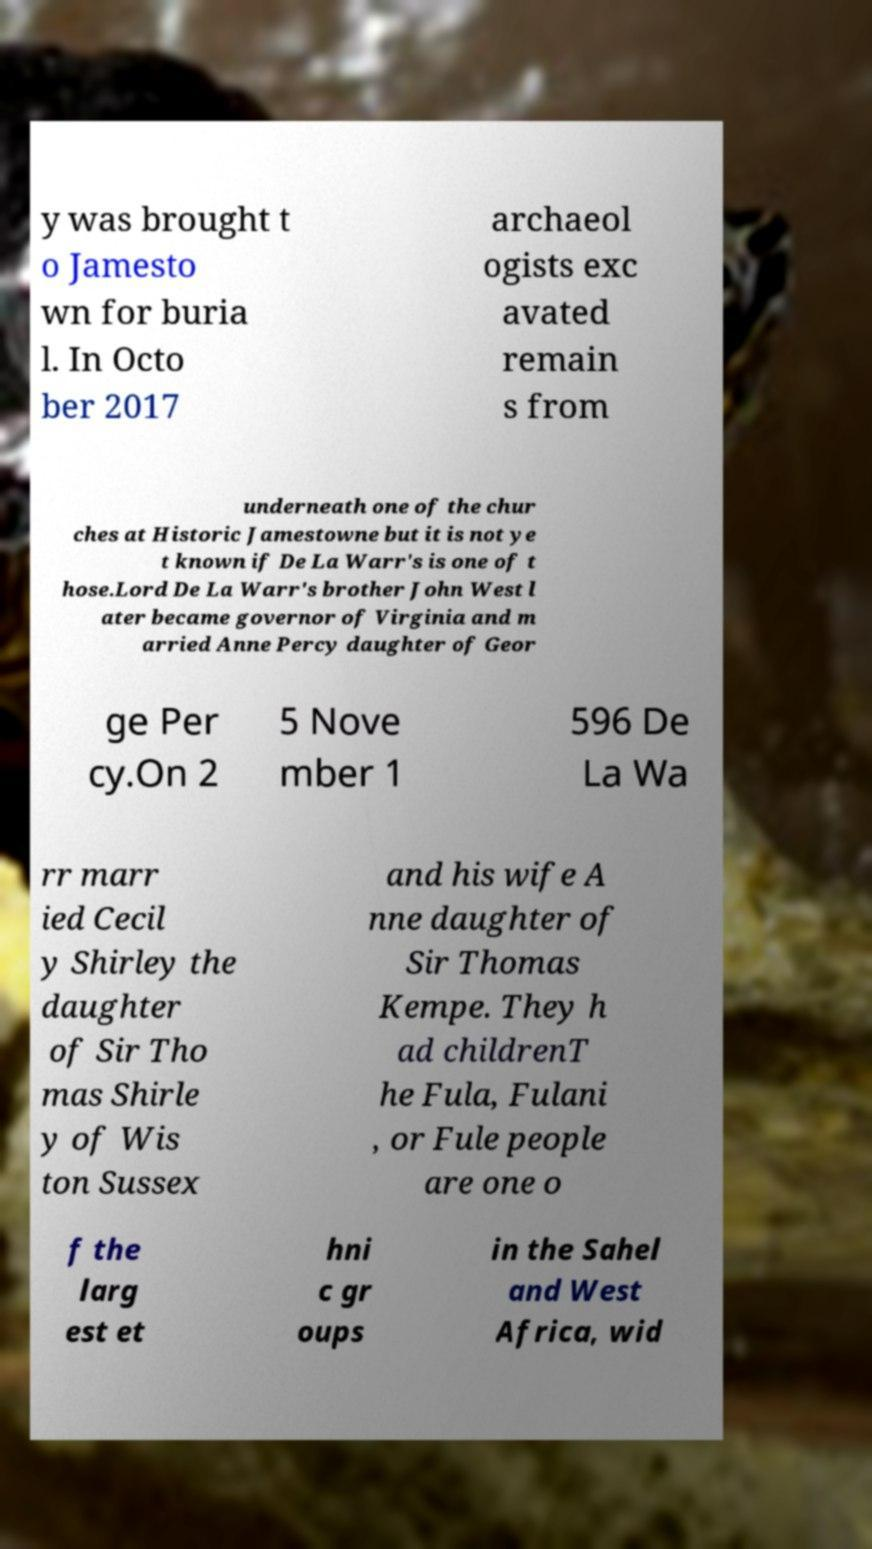Please read and relay the text visible in this image. What does it say? y was brought t o Jamesto wn for buria l. In Octo ber 2017 archaeol ogists exc avated remain s from underneath one of the chur ches at Historic Jamestowne but it is not ye t known if De La Warr's is one of t hose.Lord De La Warr's brother John West l ater became governor of Virginia and m arried Anne Percy daughter of Geor ge Per cy.On 2 5 Nove mber 1 596 De La Wa rr marr ied Cecil y Shirley the daughter of Sir Tho mas Shirle y of Wis ton Sussex and his wife A nne daughter of Sir Thomas Kempe. They h ad childrenT he Fula, Fulani , or Fule people are one o f the larg est et hni c gr oups in the Sahel and West Africa, wid 